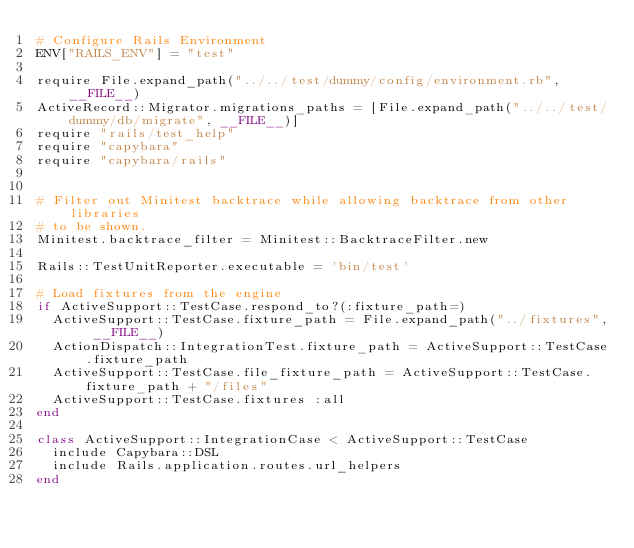<code> <loc_0><loc_0><loc_500><loc_500><_Ruby_># Configure Rails Environment
ENV["RAILS_ENV"] = "test"

require File.expand_path("../../test/dummy/config/environment.rb", __FILE__)
ActiveRecord::Migrator.migrations_paths = [File.expand_path("../../test/dummy/db/migrate", __FILE__)]
require "rails/test_help"
require "capybara"
require "capybara/rails"


# Filter out Minitest backtrace while allowing backtrace from other libraries
# to be shown.
Minitest.backtrace_filter = Minitest::BacktraceFilter.new

Rails::TestUnitReporter.executable = 'bin/test'

# Load fixtures from the engine
if ActiveSupport::TestCase.respond_to?(:fixture_path=)
  ActiveSupport::TestCase.fixture_path = File.expand_path("../fixtures", __FILE__)
  ActionDispatch::IntegrationTest.fixture_path = ActiveSupport::TestCase.fixture_path
  ActiveSupport::TestCase.file_fixture_path = ActiveSupport::TestCase.fixture_path + "/files"
  ActiveSupport::TestCase.fixtures :all
end

class ActiveSupport::IntegrationCase < ActiveSupport::TestCase
  include Capybara::DSL
  include Rails.application.routes.url_helpers
end</code> 